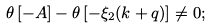Convert formula to latex. <formula><loc_0><loc_0><loc_500><loc_500>\theta \left [ - A \right ] - \theta \left [ - \xi _ { 2 } ( { k } + { q } ) \right ] \neq 0 ;</formula> 